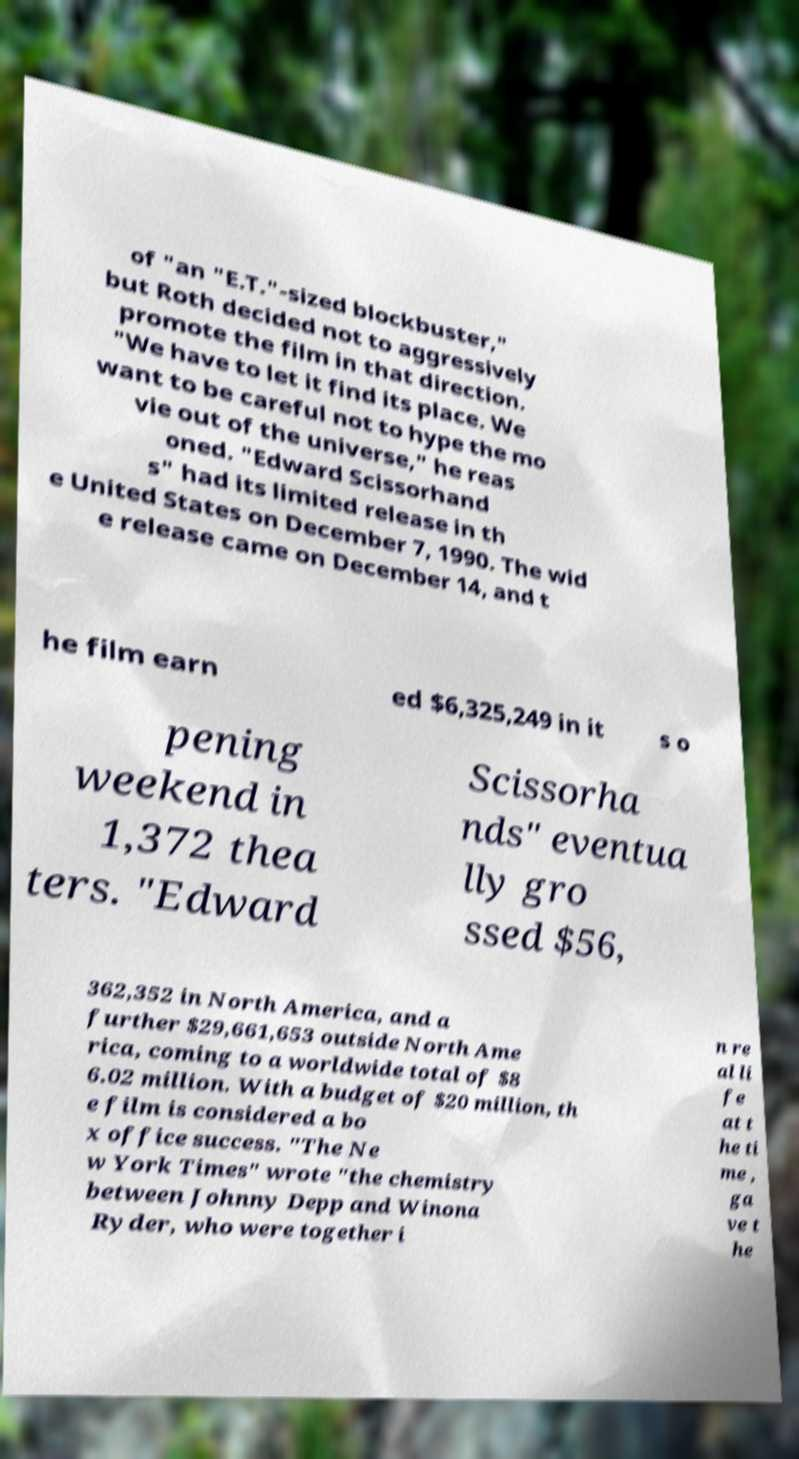What messages or text are displayed in this image? I need them in a readable, typed format. of "an "E.T."-sized blockbuster," but Roth decided not to aggressively promote the film in that direction. "We have to let it find its place. We want to be careful not to hype the mo vie out of the universe," he reas oned. "Edward Scissorhand s" had its limited release in th e United States on December 7, 1990. The wid e release came on December 14, and t he film earn ed $6,325,249 in it s o pening weekend in 1,372 thea ters. "Edward Scissorha nds" eventua lly gro ssed $56, 362,352 in North America, and a further $29,661,653 outside North Ame rica, coming to a worldwide total of $8 6.02 million. With a budget of $20 million, th e film is considered a bo x office success. "The Ne w York Times" wrote "the chemistry between Johnny Depp and Winona Ryder, who were together i n re al li fe at t he ti me , ga ve t he 